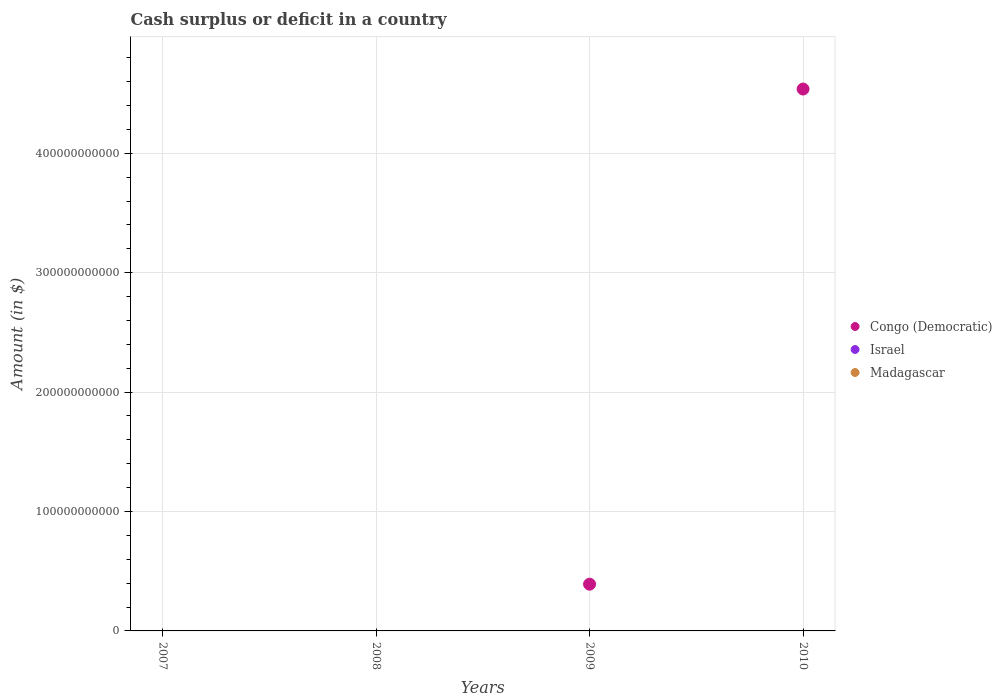Is the number of dotlines equal to the number of legend labels?
Offer a terse response. No. Across all years, what is the maximum amount of cash surplus or deficit in Congo (Democratic)?
Provide a short and direct response. 4.54e+11. What is the total amount of cash surplus or deficit in Israel in the graph?
Your response must be concise. 0. What is the difference between the amount of cash surplus or deficit in Madagascar in 2007 and the amount of cash surplus or deficit in Congo (Democratic) in 2008?
Provide a succinct answer. 0. What is the average amount of cash surplus or deficit in Congo (Democratic) per year?
Give a very brief answer. 1.23e+11. In how many years, is the amount of cash surplus or deficit in Congo (Democratic) greater than 300000000000 $?
Your answer should be very brief. 1. What is the ratio of the amount of cash surplus or deficit in Congo (Democratic) in 2009 to that in 2010?
Your response must be concise. 0.09. What is the difference between the highest and the lowest amount of cash surplus or deficit in Congo (Democratic)?
Offer a terse response. 4.54e+11. Is the amount of cash surplus or deficit in Israel strictly greater than the amount of cash surplus or deficit in Madagascar over the years?
Ensure brevity in your answer.  Yes. Is the amount of cash surplus or deficit in Madagascar strictly less than the amount of cash surplus or deficit in Congo (Democratic) over the years?
Provide a succinct answer. Yes. How many dotlines are there?
Provide a short and direct response. 1. How many years are there in the graph?
Give a very brief answer. 4. What is the difference between two consecutive major ticks on the Y-axis?
Offer a very short reply. 1.00e+11. Are the values on the major ticks of Y-axis written in scientific E-notation?
Make the answer very short. No. Does the graph contain any zero values?
Make the answer very short. Yes. Where does the legend appear in the graph?
Offer a very short reply. Center right. How many legend labels are there?
Your answer should be very brief. 3. How are the legend labels stacked?
Provide a succinct answer. Vertical. What is the title of the graph?
Your answer should be compact. Cash surplus or deficit in a country. Does "Tanzania" appear as one of the legend labels in the graph?
Your answer should be very brief. No. What is the label or title of the X-axis?
Give a very brief answer. Years. What is the label or title of the Y-axis?
Offer a terse response. Amount (in $). What is the Amount (in $) in Congo (Democratic) in 2007?
Offer a very short reply. 0. What is the Amount (in $) of Israel in 2007?
Your answer should be very brief. 0. What is the Amount (in $) of Madagascar in 2007?
Offer a very short reply. 0. What is the Amount (in $) of Israel in 2008?
Offer a terse response. 0. What is the Amount (in $) in Congo (Democratic) in 2009?
Your answer should be compact. 3.91e+1. What is the Amount (in $) of Madagascar in 2009?
Your response must be concise. 0. What is the Amount (in $) of Congo (Democratic) in 2010?
Make the answer very short. 4.54e+11. What is the Amount (in $) of Israel in 2010?
Ensure brevity in your answer.  0. Across all years, what is the maximum Amount (in $) in Congo (Democratic)?
Give a very brief answer. 4.54e+11. What is the total Amount (in $) in Congo (Democratic) in the graph?
Your response must be concise. 4.93e+11. What is the total Amount (in $) in Israel in the graph?
Your response must be concise. 0. What is the difference between the Amount (in $) of Congo (Democratic) in 2009 and that in 2010?
Your response must be concise. -4.15e+11. What is the average Amount (in $) of Congo (Democratic) per year?
Offer a terse response. 1.23e+11. What is the average Amount (in $) of Israel per year?
Your response must be concise. 0. What is the average Amount (in $) of Madagascar per year?
Make the answer very short. 0. What is the ratio of the Amount (in $) of Congo (Democratic) in 2009 to that in 2010?
Provide a short and direct response. 0.09. What is the difference between the highest and the lowest Amount (in $) in Congo (Democratic)?
Provide a succinct answer. 4.54e+11. 